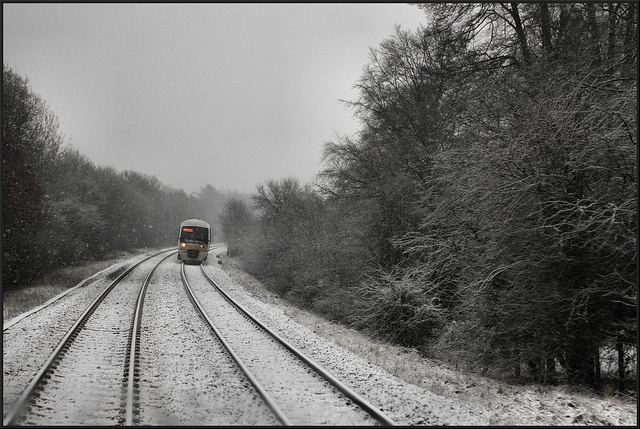Describe the objects in this image and their specific colors. I can see a train in black, gray, and darkgray tones in this image. 